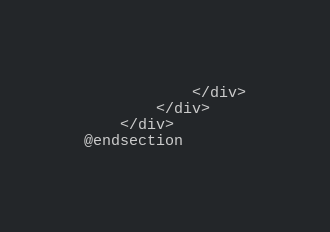<code> <loc_0><loc_0><loc_500><loc_500><_PHP_>            </div>
        </div>
    </div>
@endsection
</code> 